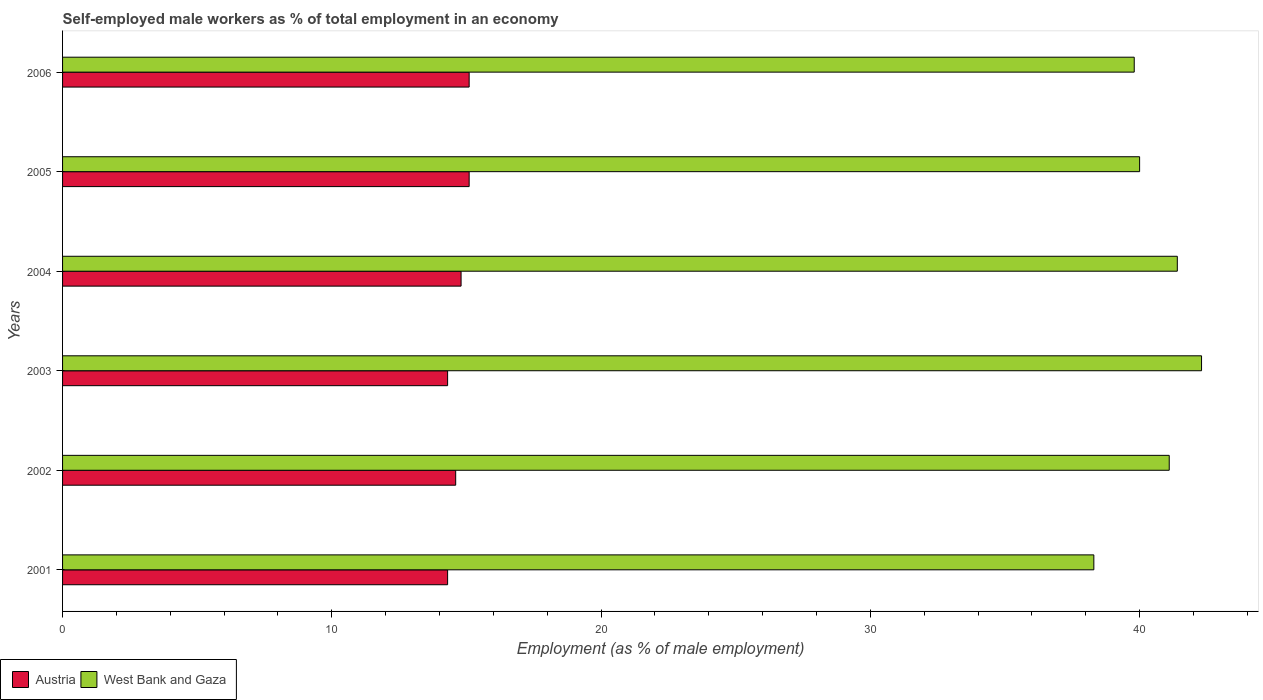How many groups of bars are there?
Provide a succinct answer. 6. Are the number of bars on each tick of the Y-axis equal?
Offer a terse response. Yes. How many bars are there on the 5th tick from the top?
Your answer should be very brief. 2. What is the percentage of self-employed male workers in West Bank and Gaza in 2003?
Your response must be concise. 42.3. Across all years, what is the maximum percentage of self-employed male workers in Austria?
Offer a very short reply. 15.1. Across all years, what is the minimum percentage of self-employed male workers in West Bank and Gaza?
Offer a very short reply. 38.3. What is the total percentage of self-employed male workers in Austria in the graph?
Offer a terse response. 88.2. What is the difference between the percentage of self-employed male workers in West Bank and Gaza in 2003 and the percentage of self-employed male workers in Austria in 2002?
Make the answer very short. 27.7. What is the average percentage of self-employed male workers in Austria per year?
Give a very brief answer. 14.7. In the year 2005, what is the difference between the percentage of self-employed male workers in Austria and percentage of self-employed male workers in West Bank and Gaza?
Keep it short and to the point. -24.9. What is the ratio of the percentage of self-employed male workers in West Bank and Gaza in 2004 to that in 2005?
Make the answer very short. 1.04. Is the percentage of self-employed male workers in West Bank and Gaza in 2003 less than that in 2006?
Your answer should be compact. No. What is the difference between the highest and the second highest percentage of self-employed male workers in West Bank and Gaza?
Offer a terse response. 0.9. What is the difference between the highest and the lowest percentage of self-employed male workers in West Bank and Gaza?
Ensure brevity in your answer.  4. Is the sum of the percentage of self-employed male workers in Austria in 2001 and 2005 greater than the maximum percentage of self-employed male workers in West Bank and Gaza across all years?
Make the answer very short. No. What does the 1st bar from the top in 2006 represents?
Ensure brevity in your answer.  West Bank and Gaza. How many bars are there?
Provide a short and direct response. 12. Does the graph contain any zero values?
Offer a very short reply. No. Does the graph contain grids?
Your answer should be very brief. No. Where does the legend appear in the graph?
Ensure brevity in your answer.  Bottom left. How many legend labels are there?
Your response must be concise. 2. What is the title of the graph?
Offer a very short reply. Self-employed male workers as % of total employment in an economy. Does "Iceland" appear as one of the legend labels in the graph?
Make the answer very short. No. What is the label or title of the X-axis?
Give a very brief answer. Employment (as % of male employment). What is the label or title of the Y-axis?
Your answer should be very brief. Years. What is the Employment (as % of male employment) in Austria in 2001?
Keep it short and to the point. 14.3. What is the Employment (as % of male employment) of West Bank and Gaza in 2001?
Give a very brief answer. 38.3. What is the Employment (as % of male employment) in Austria in 2002?
Your response must be concise. 14.6. What is the Employment (as % of male employment) in West Bank and Gaza in 2002?
Offer a terse response. 41.1. What is the Employment (as % of male employment) in Austria in 2003?
Your answer should be compact. 14.3. What is the Employment (as % of male employment) of West Bank and Gaza in 2003?
Ensure brevity in your answer.  42.3. What is the Employment (as % of male employment) in Austria in 2004?
Your answer should be compact. 14.8. What is the Employment (as % of male employment) in West Bank and Gaza in 2004?
Your answer should be very brief. 41.4. What is the Employment (as % of male employment) of Austria in 2005?
Your response must be concise. 15.1. What is the Employment (as % of male employment) in Austria in 2006?
Offer a terse response. 15.1. What is the Employment (as % of male employment) of West Bank and Gaza in 2006?
Give a very brief answer. 39.8. Across all years, what is the maximum Employment (as % of male employment) in Austria?
Offer a very short reply. 15.1. Across all years, what is the maximum Employment (as % of male employment) of West Bank and Gaza?
Offer a terse response. 42.3. Across all years, what is the minimum Employment (as % of male employment) of Austria?
Offer a very short reply. 14.3. Across all years, what is the minimum Employment (as % of male employment) in West Bank and Gaza?
Your answer should be very brief. 38.3. What is the total Employment (as % of male employment) of Austria in the graph?
Your answer should be very brief. 88.2. What is the total Employment (as % of male employment) of West Bank and Gaza in the graph?
Provide a succinct answer. 242.9. What is the difference between the Employment (as % of male employment) of Austria in 2001 and that in 2003?
Your response must be concise. 0. What is the difference between the Employment (as % of male employment) in West Bank and Gaza in 2001 and that in 2003?
Provide a short and direct response. -4. What is the difference between the Employment (as % of male employment) of West Bank and Gaza in 2001 and that in 2004?
Make the answer very short. -3.1. What is the difference between the Employment (as % of male employment) in Austria in 2001 and that in 2005?
Offer a terse response. -0.8. What is the difference between the Employment (as % of male employment) of Austria in 2001 and that in 2006?
Your response must be concise. -0.8. What is the difference between the Employment (as % of male employment) of West Bank and Gaza in 2001 and that in 2006?
Make the answer very short. -1.5. What is the difference between the Employment (as % of male employment) of Austria in 2002 and that in 2003?
Your answer should be very brief. 0.3. What is the difference between the Employment (as % of male employment) of West Bank and Gaza in 2002 and that in 2003?
Make the answer very short. -1.2. What is the difference between the Employment (as % of male employment) of Austria in 2002 and that in 2004?
Give a very brief answer. -0.2. What is the difference between the Employment (as % of male employment) in Austria in 2002 and that in 2005?
Provide a short and direct response. -0.5. What is the difference between the Employment (as % of male employment) of West Bank and Gaza in 2002 and that in 2005?
Your answer should be compact. 1.1. What is the difference between the Employment (as % of male employment) in Austria in 2002 and that in 2006?
Provide a succinct answer. -0.5. What is the difference between the Employment (as % of male employment) of Austria in 2003 and that in 2004?
Provide a short and direct response. -0.5. What is the difference between the Employment (as % of male employment) in Austria in 2003 and that in 2005?
Your answer should be very brief. -0.8. What is the difference between the Employment (as % of male employment) in Austria in 2003 and that in 2006?
Offer a very short reply. -0.8. What is the difference between the Employment (as % of male employment) in Austria in 2004 and that in 2005?
Your response must be concise. -0.3. What is the difference between the Employment (as % of male employment) of West Bank and Gaza in 2004 and that in 2006?
Make the answer very short. 1.6. What is the difference between the Employment (as % of male employment) of West Bank and Gaza in 2005 and that in 2006?
Ensure brevity in your answer.  0.2. What is the difference between the Employment (as % of male employment) of Austria in 2001 and the Employment (as % of male employment) of West Bank and Gaza in 2002?
Ensure brevity in your answer.  -26.8. What is the difference between the Employment (as % of male employment) in Austria in 2001 and the Employment (as % of male employment) in West Bank and Gaza in 2004?
Your answer should be compact. -27.1. What is the difference between the Employment (as % of male employment) of Austria in 2001 and the Employment (as % of male employment) of West Bank and Gaza in 2005?
Your answer should be compact. -25.7. What is the difference between the Employment (as % of male employment) of Austria in 2001 and the Employment (as % of male employment) of West Bank and Gaza in 2006?
Provide a short and direct response. -25.5. What is the difference between the Employment (as % of male employment) of Austria in 2002 and the Employment (as % of male employment) of West Bank and Gaza in 2003?
Give a very brief answer. -27.7. What is the difference between the Employment (as % of male employment) of Austria in 2002 and the Employment (as % of male employment) of West Bank and Gaza in 2004?
Offer a terse response. -26.8. What is the difference between the Employment (as % of male employment) in Austria in 2002 and the Employment (as % of male employment) in West Bank and Gaza in 2005?
Offer a very short reply. -25.4. What is the difference between the Employment (as % of male employment) in Austria in 2002 and the Employment (as % of male employment) in West Bank and Gaza in 2006?
Your answer should be compact. -25.2. What is the difference between the Employment (as % of male employment) of Austria in 2003 and the Employment (as % of male employment) of West Bank and Gaza in 2004?
Your response must be concise. -27.1. What is the difference between the Employment (as % of male employment) of Austria in 2003 and the Employment (as % of male employment) of West Bank and Gaza in 2005?
Your response must be concise. -25.7. What is the difference between the Employment (as % of male employment) of Austria in 2003 and the Employment (as % of male employment) of West Bank and Gaza in 2006?
Your answer should be very brief. -25.5. What is the difference between the Employment (as % of male employment) in Austria in 2004 and the Employment (as % of male employment) in West Bank and Gaza in 2005?
Ensure brevity in your answer.  -25.2. What is the difference between the Employment (as % of male employment) of Austria in 2004 and the Employment (as % of male employment) of West Bank and Gaza in 2006?
Your answer should be compact. -25. What is the difference between the Employment (as % of male employment) in Austria in 2005 and the Employment (as % of male employment) in West Bank and Gaza in 2006?
Provide a short and direct response. -24.7. What is the average Employment (as % of male employment) of West Bank and Gaza per year?
Your response must be concise. 40.48. In the year 2002, what is the difference between the Employment (as % of male employment) of Austria and Employment (as % of male employment) of West Bank and Gaza?
Provide a short and direct response. -26.5. In the year 2004, what is the difference between the Employment (as % of male employment) of Austria and Employment (as % of male employment) of West Bank and Gaza?
Your answer should be compact. -26.6. In the year 2005, what is the difference between the Employment (as % of male employment) in Austria and Employment (as % of male employment) in West Bank and Gaza?
Give a very brief answer. -24.9. In the year 2006, what is the difference between the Employment (as % of male employment) in Austria and Employment (as % of male employment) in West Bank and Gaza?
Make the answer very short. -24.7. What is the ratio of the Employment (as % of male employment) in Austria in 2001 to that in 2002?
Give a very brief answer. 0.98. What is the ratio of the Employment (as % of male employment) in West Bank and Gaza in 2001 to that in 2002?
Offer a terse response. 0.93. What is the ratio of the Employment (as % of male employment) in Austria in 2001 to that in 2003?
Your answer should be very brief. 1. What is the ratio of the Employment (as % of male employment) of West Bank and Gaza in 2001 to that in 2003?
Provide a succinct answer. 0.91. What is the ratio of the Employment (as % of male employment) of Austria in 2001 to that in 2004?
Keep it short and to the point. 0.97. What is the ratio of the Employment (as % of male employment) in West Bank and Gaza in 2001 to that in 2004?
Keep it short and to the point. 0.93. What is the ratio of the Employment (as % of male employment) in Austria in 2001 to that in 2005?
Your response must be concise. 0.95. What is the ratio of the Employment (as % of male employment) in West Bank and Gaza in 2001 to that in 2005?
Your response must be concise. 0.96. What is the ratio of the Employment (as % of male employment) of Austria in 2001 to that in 2006?
Your answer should be very brief. 0.95. What is the ratio of the Employment (as % of male employment) of West Bank and Gaza in 2001 to that in 2006?
Offer a very short reply. 0.96. What is the ratio of the Employment (as % of male employment) in West Bank and Gaza in 2002 to that in 2003?
Your response must be concise. 0.97. What is the ratio of the Employment (as % of male employment) of Austria in 2002 to that in 2004?
Ensure brevity in your answer.  0.99. What is the ratio of the Employment (as % of male employment) of Austria in 2002 to that in 2005?
Give a very brief answer. 0.97. What is the ratio of the Employment (as % of male employment) in West Bank and Gaza in 2002 to that in 2005?
Give a very brief answer. 1.03. What is the ratio of the Employment (as % of male employment) in Austria in 2002 to that in 2006?
Give a very brief answer. 0.97. What is the ratio of the Employment (as % of male employment) of West Bank and Gaza in 2002 to that in 2006?
Offer a terse response. 1.03. What is the ratio of the Employment (as % of male employment) of Austria in 2003 to that in 2004?
Your response must be concise. 0.97. What is the ratio of the Employment (as % of male employment) of West Bank and Gaza in 2003 to that in 2004?
Provide a short and direct response. 1.02. What is the ratio of the Employment (as % of male employment) in Austria in 2003 to that in 2005?
Keep it short and to the point. 0.95. What is the ratio of the Employment (as % of male employment) of West Bank and Gaza in 2003 to that in 2005?
Your response must be concise. 1.06. What is the ratio of the Employment (as % of male employment) in Austria in 2003 to that in 2006?
Offer a terse response. 0.95. What is the ratio of the Employment (as % of male employment) of West Bank and Gaza in 2003 to that in 2006?
Your answer should be compact. 1.06. What is the ratio of the Employment (as % of male employment) of Austria in 2004 to that in 2005?
Provide a short and direct response. 0.98. What is the ratio of the Employment (as % of male employment) of West Bank and Gaza in 2004 to that in 2005?
Give a very brief answer. 1.03. What is the ratio of the Employment (as % of male employment) in Austria in 2004 to that in 2006?
Ensure brevity in your answer.  0.98. What is the ratio of the Employment (as % of male employment) in West Bank and Gaza in 2004 to that in 2006?
Your answer should be compact. 1.04. 